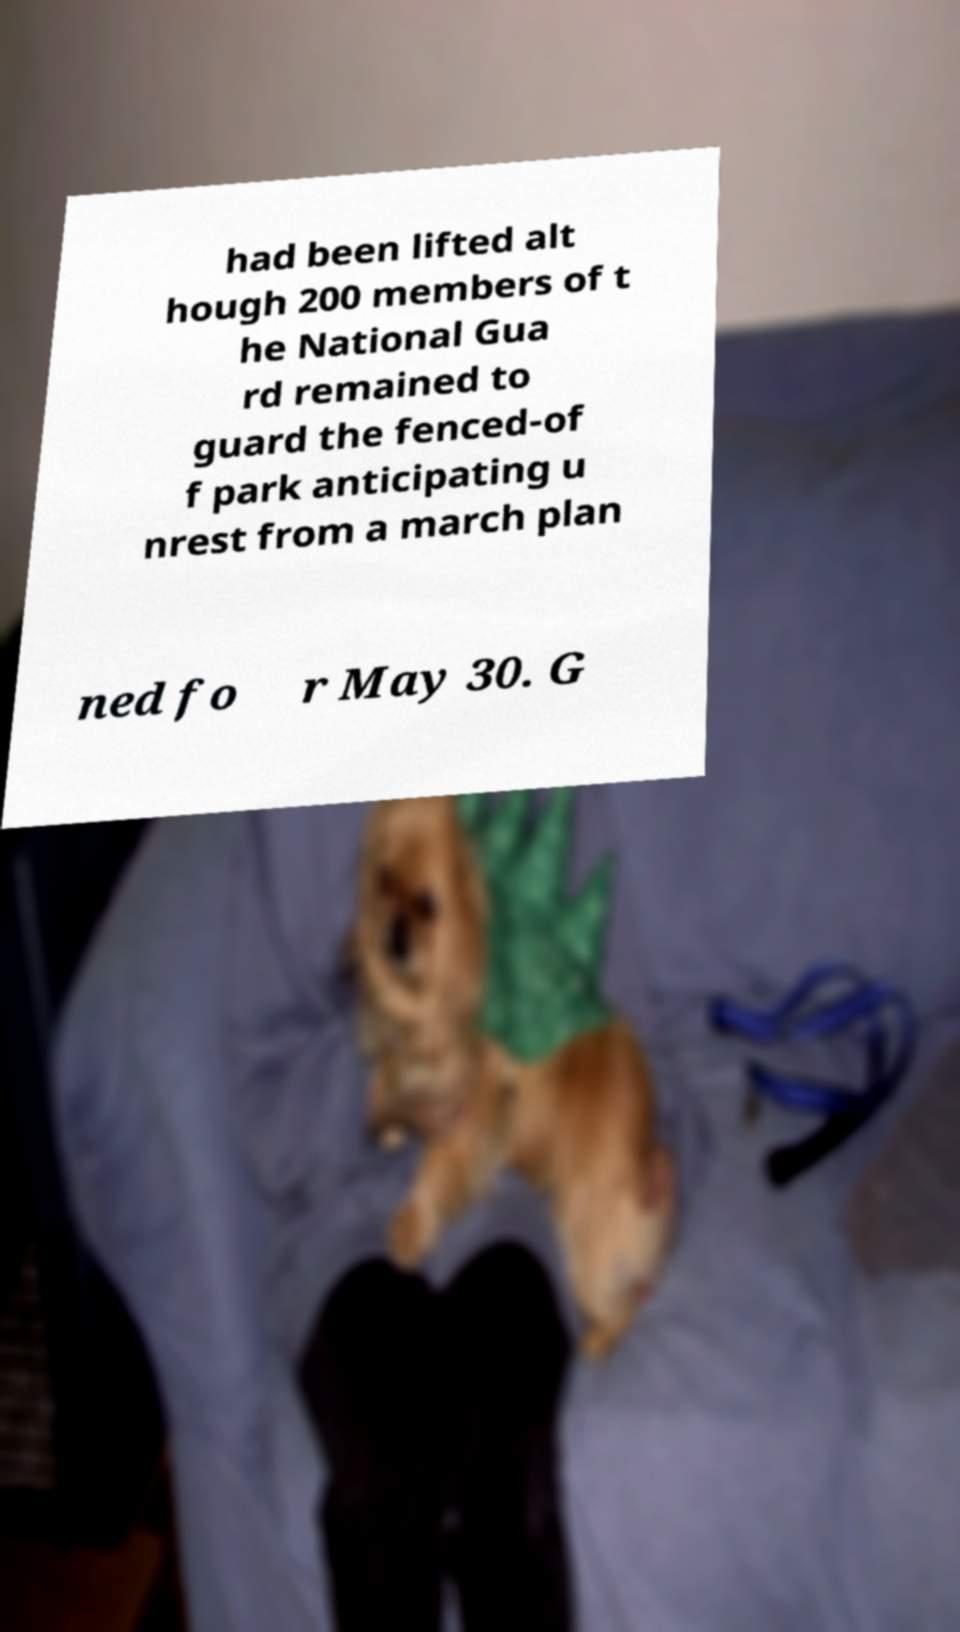Please identify and transcribe the text found in this image. had been lifted alt hough 200 members of t he National Gua rd remained to guard the fenced-of f park anticipating u nrest from a march plan ned fo r May 30. G 